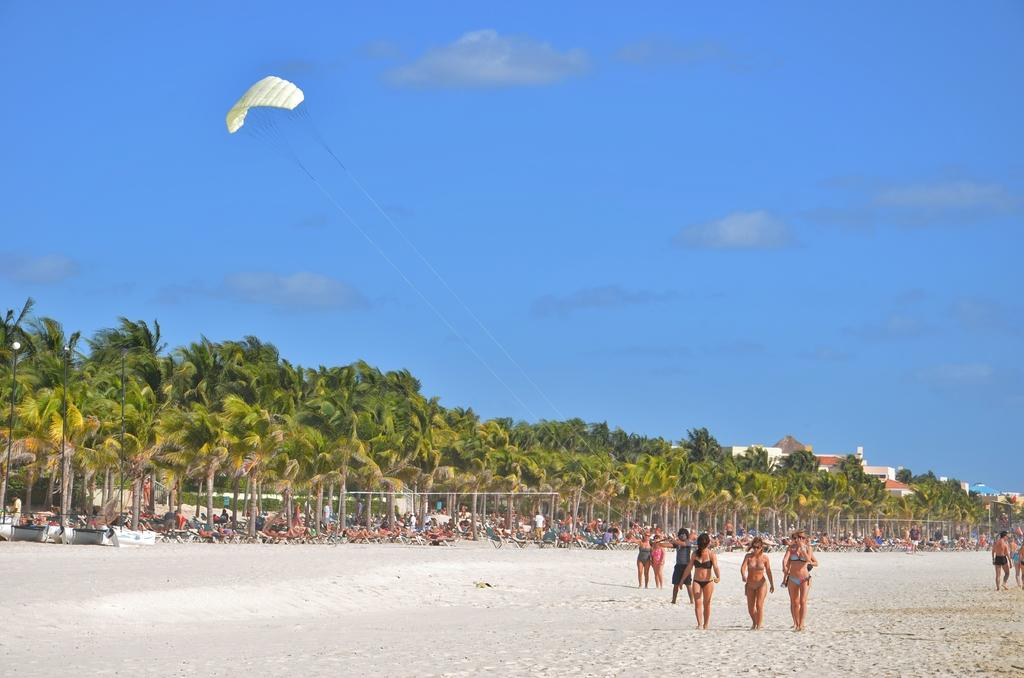What is the location of the people in the image? The people are standing near the sea beach. What are some of the people doing in the image? Some people are sitting on chairs. What type of vegetation can be seen in the image? There are trees visible in the image. What can be seen in the background of the image? There is a building in the background. What sound can be heard coming from the actor in the image? There is no actor present in the image, and therefore no sound can be heard coming from them. What type of cracker is being eaten by the people in the image? There is no cracker visible in the image, and it is not mentioned that the people are eating anything. 